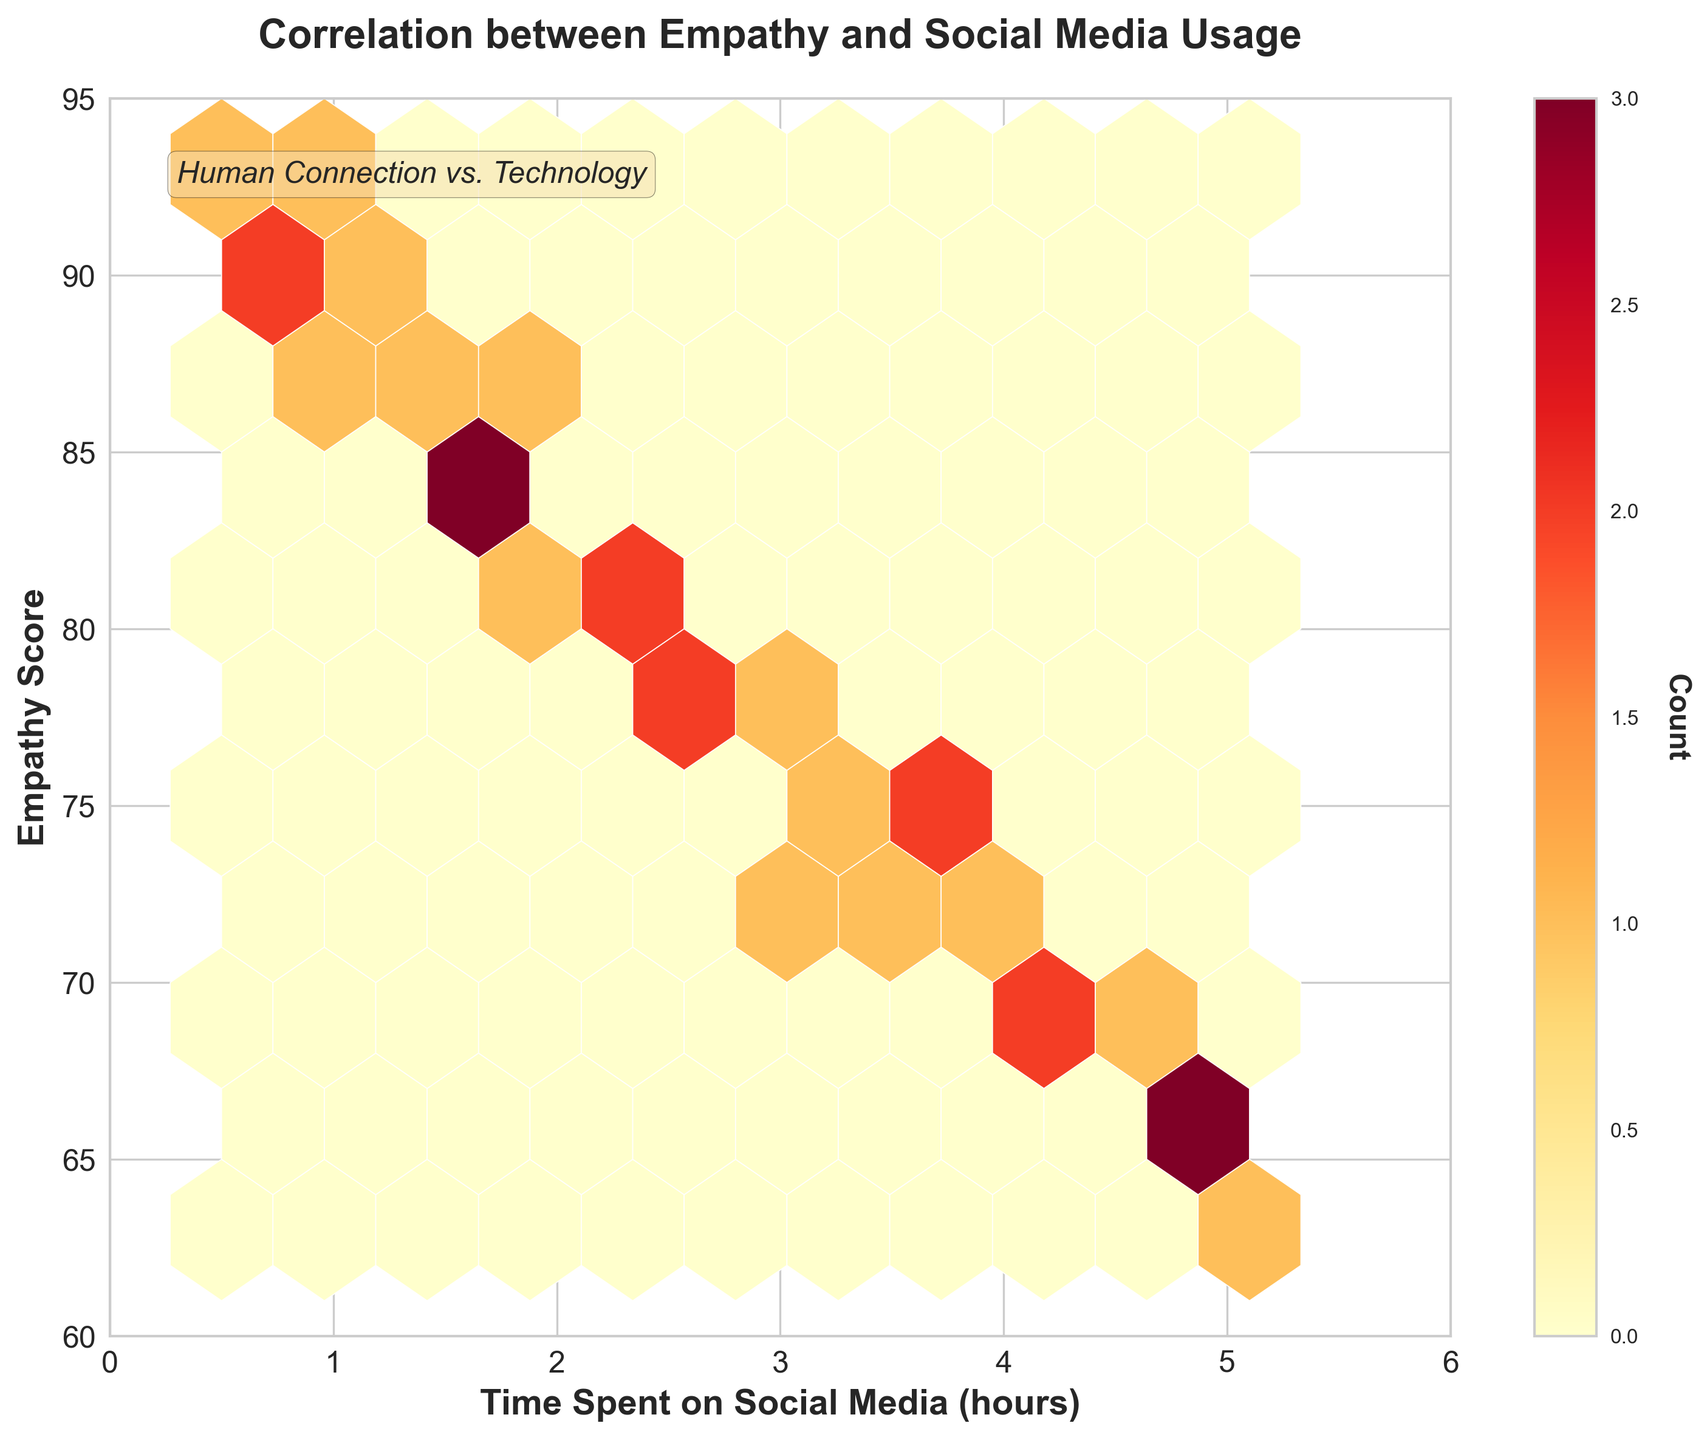What's the title of the figure? The title is clearly positioned at the top center of the plot. Reading it directly provides the answer.
Answer: Correlation between Empathy and Social Media Usage What are the labels of the x and y axes? The x-axis and y-axis labels are visible and easy to read. The x-axis label is below the axis, and the y-axis label is to the left of the axis.
Answer: Time Spent on Social Media (hours), Empathy Score What is the color representing the highest bin count in the hexbin plot? The hexbin plot uses a color map with gradations. The brightest color (red) represents the highest bin count, as indicated in the color bar.
Answer: Red In which range can you find the majority of social media usage hours? The majority of data points (highlighted by the density of hexagons) are found in the lower range of the x-axis.
Answer: 0 to 3 hours Which range of empathy scores appears more frequently when social media hours are between 3 and 5? By observing the density of hexagons in the 3 to 5 social media hours range, one can infer the corresponding empathy score ranges with higher frequencies.
Answer: 65 to 75 What can you say about the relationship between time spent on social media and empathy scores based on this plot? By interpreting the figure, it is apparent that higher social media usage (right side of the x-axis) clusters with lower empathy scores (bottom side of the y-axis).
Answer: Negative correlation How does the empathy score range vary as social media hours increase from 0 to 6 hours? Analyzing the hexbin density from low to high social media hours, the empathy scores tend to decrease as hours increase, shown by higher densities on the lower-left side of the plot.
Answer: Decreases What is the approximate range of empathy scores for people who spend less than 2 hours on social media? Looking at the density of hexagons on the left side of the x-axis, the corresponding empathy scores are concentrated within a specific range.
Answer: 80 to 95 Based on the plot, which specific social media usage hour has the highest empathy scores clustered? Identifying the block with the highest concentration and then finding the related hours within it gives the number of social media hours with the highest empathy scores.
Answer: Very close to 1 hour 